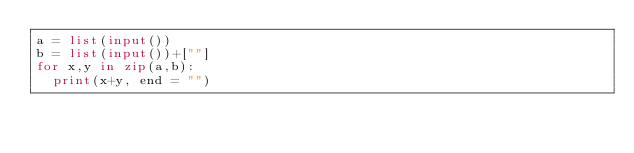Convert code to text. <code><loc_0><loc_0><loc_500><loc_500><_Python_>a = list(input())
b = list(input())+[""]
for x,y in zip(a,b):
  print(x+y, end = "")</code> 